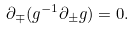Convert formula to latex. <formula><loc_0><loc_0><loc_500><loc_500>\partial _ { \mp } ( g ^ { - 1 } \partial _ { \pm } g ) = 0 .</formula> 